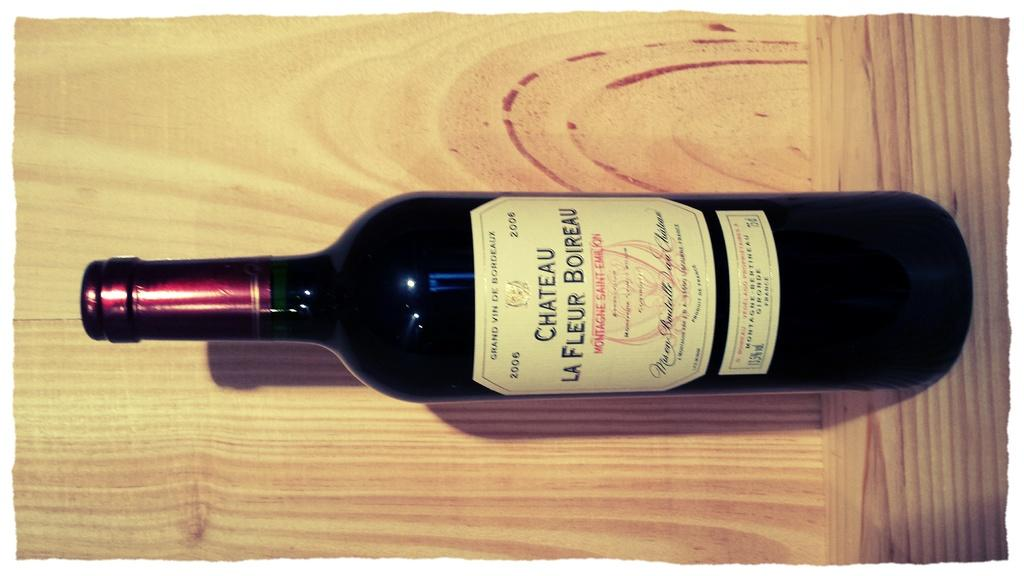Provide a one-sentence caption for the provided image. A bottle of Chateau La Fleur Boireau sits in a wooden crate. 